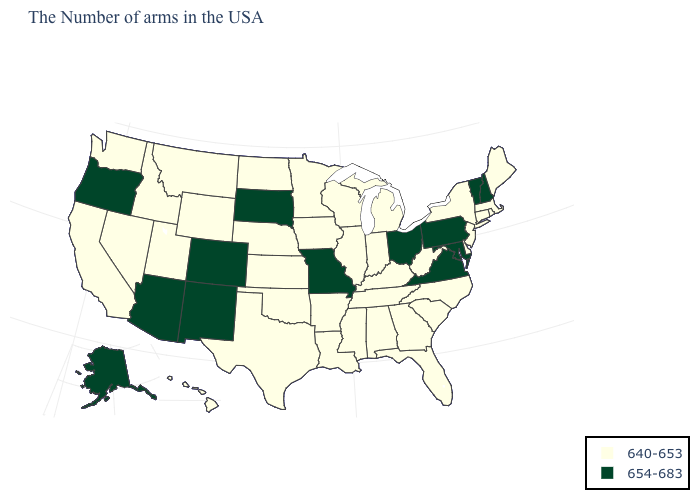What is the value of Louisiana?
Concise answer only. 640-653. Which states hav the highest value in the West?
Short answer required. Colorado, New Mexico, Arizona, Oregon, Alaska. What is the value of New Jersey?
Give a very brief answer. 640-653. Name the states that have a value in the range 654-683?
Be succinct. New Hampshire, Vermont, Maryland, Pennsylvania, Virginia, Ohio, Missouri, South Dakota, Colorado, New Mexico, Arizona, Oregon, Alaska. Does New Mexico have the highest value in the USA?
Answer briefly. Yes. Name the states that have a value in the range 640-653?
Give a very brief answer. Maine, Massachusetts, Rhode Island, Connecticut, New York, New Jersey, Delaware, North Carolina, South Carolina, West Virginia, Florida, Georgia, Michigan, Kentucky, Indiana, Alabama, Tennessee, Wisconsin, Illinois, Mississippi, Louisiana, Arkansas, Minnesota, Iowa, Kansas, Nebraska, Oklahoma, Texas, North Dakota, Wyoming, Utah, Montana, Idaho, Nevada, California, Washington, Hawaii. What is the highest value in the USA?
Concise answer only. 654-683. What is the value of Idaho?
Answer briefly. 640-653. What is the lowest value in the Northeast?
Keep it brief. 640-653. Name the states that have a value in the range 640-653?
Short answer required. Maine, Massachusetts, Rhode Island, Connecticut, New York, New Jersey, Delaware, North Carolina, South Carolina, West Virginia, Florida, Georgia, Michigan, Kentucky, Indiana, Alabama, Tennessee, Wisconsin, Illinois, Mississippi, Louisiana, Arkansas, Minnesota, Iowa, Kansas, Nebraska, Oklahoma, Texas, North Dakota, Wyoming, Utah, Montana, Idaho, Nevada, California, Washington, Hawaii. What is the lowest value in the USA?
Short answer required. 640-653. Name the states that have a value in the range 640-653?
Give a very brief answer. Maine, Massachusetts, Rhode Island, Connecticut, New York, New Jersey, Delaware, North Carolina, South Carolina, West Virginia, Florida, Georgia, Michigan, Kentucky, Indiana, Alabama, Tennessee, Wisconsin, Illinois, Mississippi, Louisiana, Arkansas, Minnesota, Iowa, Kansas, Nebraska, Oklahoma, Texas, North Dakota, Wyoming, Utah, Montana, Idaho, Nevada, California, Washington, Hawaii. What is the lowest value in the USA?
Quick response, please. 640-653. Which states have the lowest value in the USA?
Concise answer only. Maine, Massachusetts, Rhode Island, Connecticut, New York, New Jersey, Delaware, North Carolina, South Carolina, West Virginia, Florida, Georgia, Michigan, Kentucky, Indiana, Alabama, Tennessee, Wisconsin, Illinois, Mississippi, Louisiana, Arkansas, Minnesota, Iowa, Kansas, Nebraska, Oklahoma, Texas, North Dakota, Wyoming, Utah, Montana, Idaho, Nevada, California, Washington, Hawaii. What is the highest value in states that border Arkansas?
Short answer required. 654-683. 